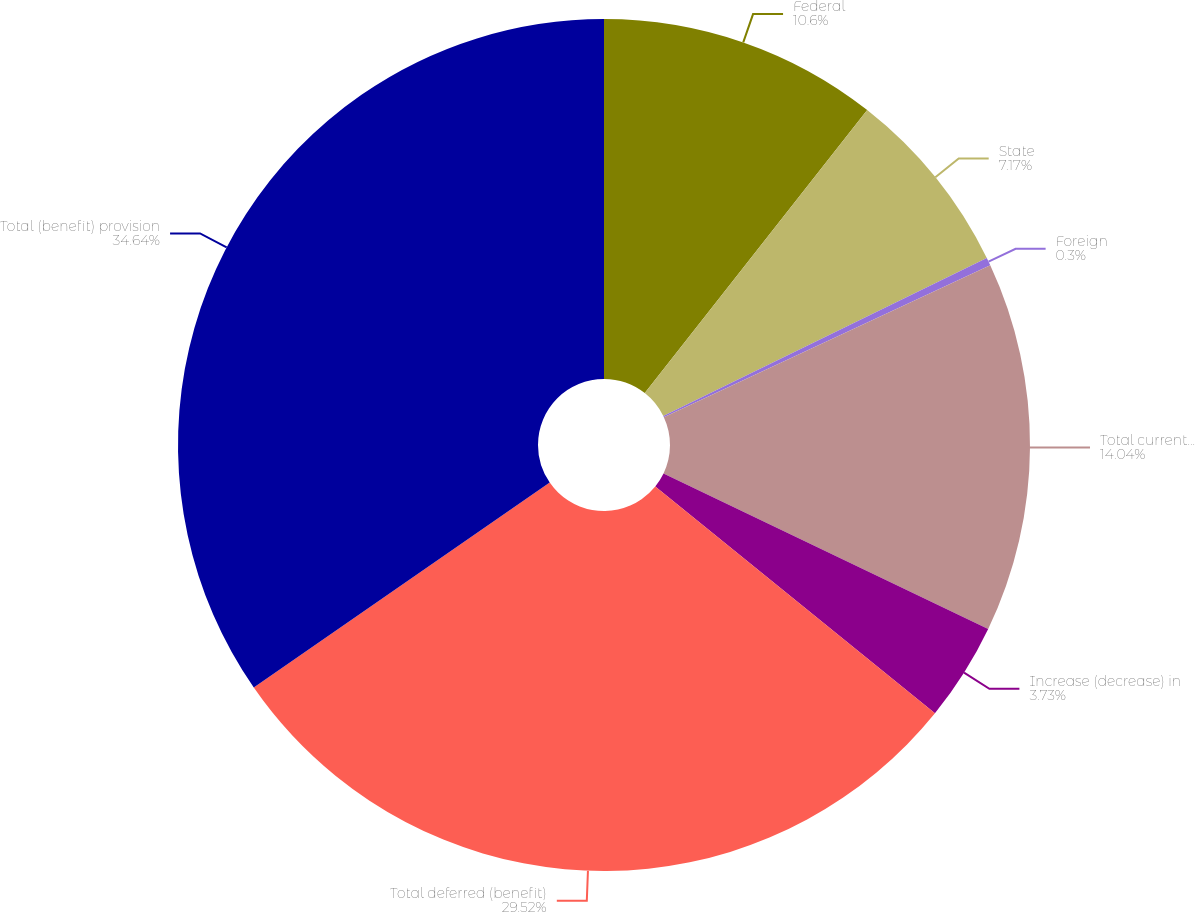Convert chart to OTSL. <chart><loc_0><loc_0><loc_500><loc_500><pie_chart><fcel>Federal<fcel>State<fcel>Foreign<fcel>Total current (benefit)<fcel>Increase (decrease) in<fcel>Total deferred (benefit)<fcel>Total (benefit) provision<nl><fcel>10.6%<fcel>7.17%<fcel>0.3%<fcel>14.04%<fcel>3.73%<fcel>29.52%<fcel>34.64%<nl></chart> 